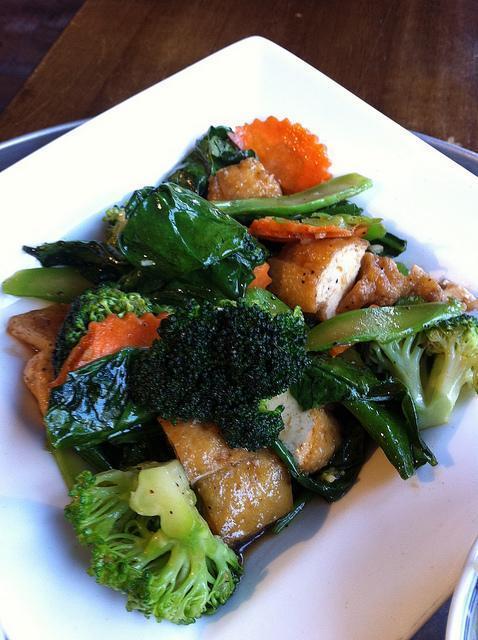How many bowls are there?
Give a very brief answer. 2. How many carrots are visible?
Give a very brief answer. 2. How many broccolis can be seen?
Give a very brief answer. 4. How many people are wearing a red shirt?
Give a very brief answer. 0. 